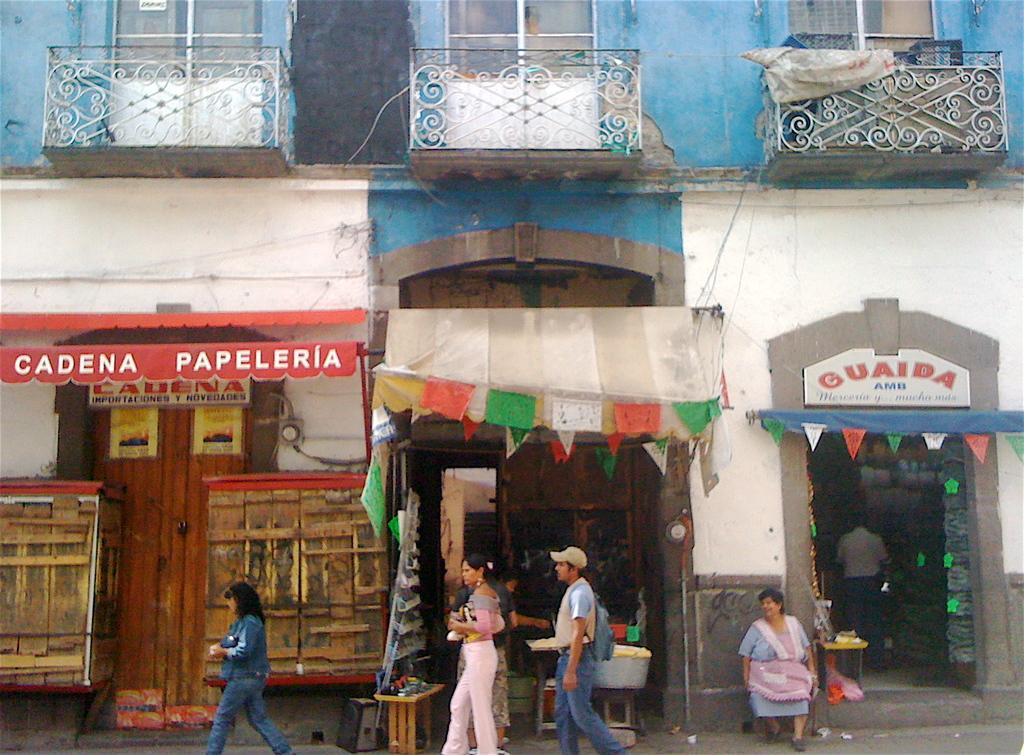What are the persons in the image doing? The persons in the image are walking on the road. What are the persons holding? The persons are holding items. What can be seen in terms of commercial establishments in the image? There are shops with names in the image. Can you describe any specific design elements in the image? There is a designer curtain visible, and there is a wall with a designed fence. What is the purpose of the flag in the image? The purpose of the flag in the image is not specified, but it may represent a country, organization, or event. What type of stocking is being worn by the persons in the image? There is no information about the type of stocking being worn by the persons in the image. Can you tell me how many baseballs are visible in the image? There are no baseballs present in the image. 